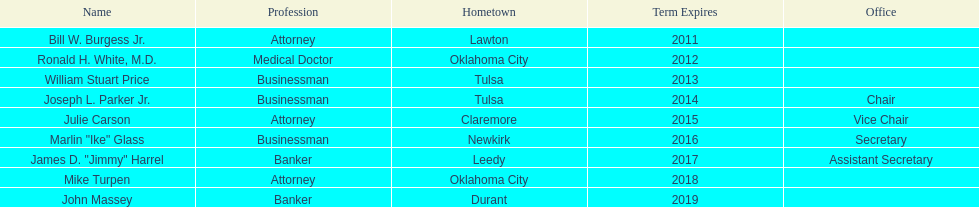Excluding william stuart price, which other commerce individual was born in tulsa? Joseph L. Parker Jr. 